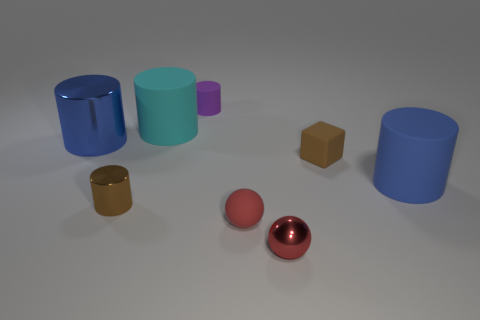Subtract 1 cylinders. How many cylinders are left? 4 Subtract all brown cylinders. How many cylinders are left? 4 Subtract all large blue rubber cylinders. How many cylinders are left? 4 Subtract all red cylinders. Subtract all purple blocks. How many cylinders are left? 5 Add 1 small purple rubber cylinders. How many objects exist? 9 Subtract all blocks. How many objects are left? 7 Subtract all cyan cylinders. Subtract all tiny red balls. How many objects are left? 5 Add 7 small cubes. How many small cubes are left? 8 Add 5 tiny red spheres. How many tiny red spheres exist? 7 Subtract 0 green blocks. How many objects are left? 8 